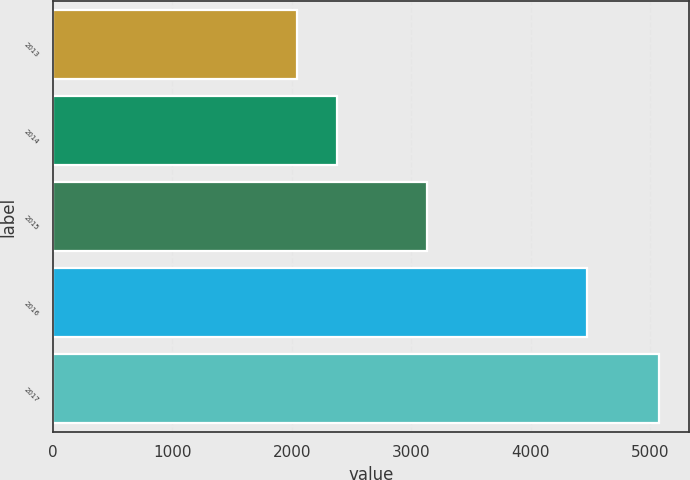Convert chart. <chart><loc_0><loc_0><loc_500><loc_500><bar_chart><fcel>2013<fcel>2014<fcel>2015<fcel>2016<fcel>2017<nl><fcel>2045<fcel>2382<fcel>3129<fcel>4466<fcel>5068<nl></chart> 